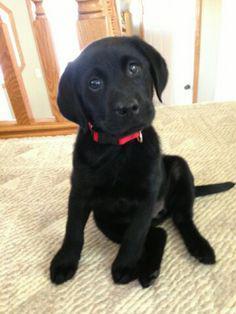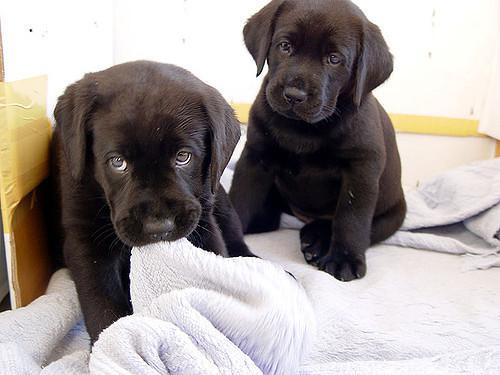The first image is the image on the left, the second image is the image on the right. For the images shown, is this caption "Both images contain the same number of puppies." true? Answer yes or no. No. 